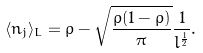<formula> <loc_0><loc_0><loc_500><loc_500>\langle n _ { j } \rangle _ { L } = \rho - \sqrt { \frac { \rho ( 1 - \rho ) } { \pi } } \frac { 1 } { l ^ { \frac { 1 } { 2 } } } .</formula> 